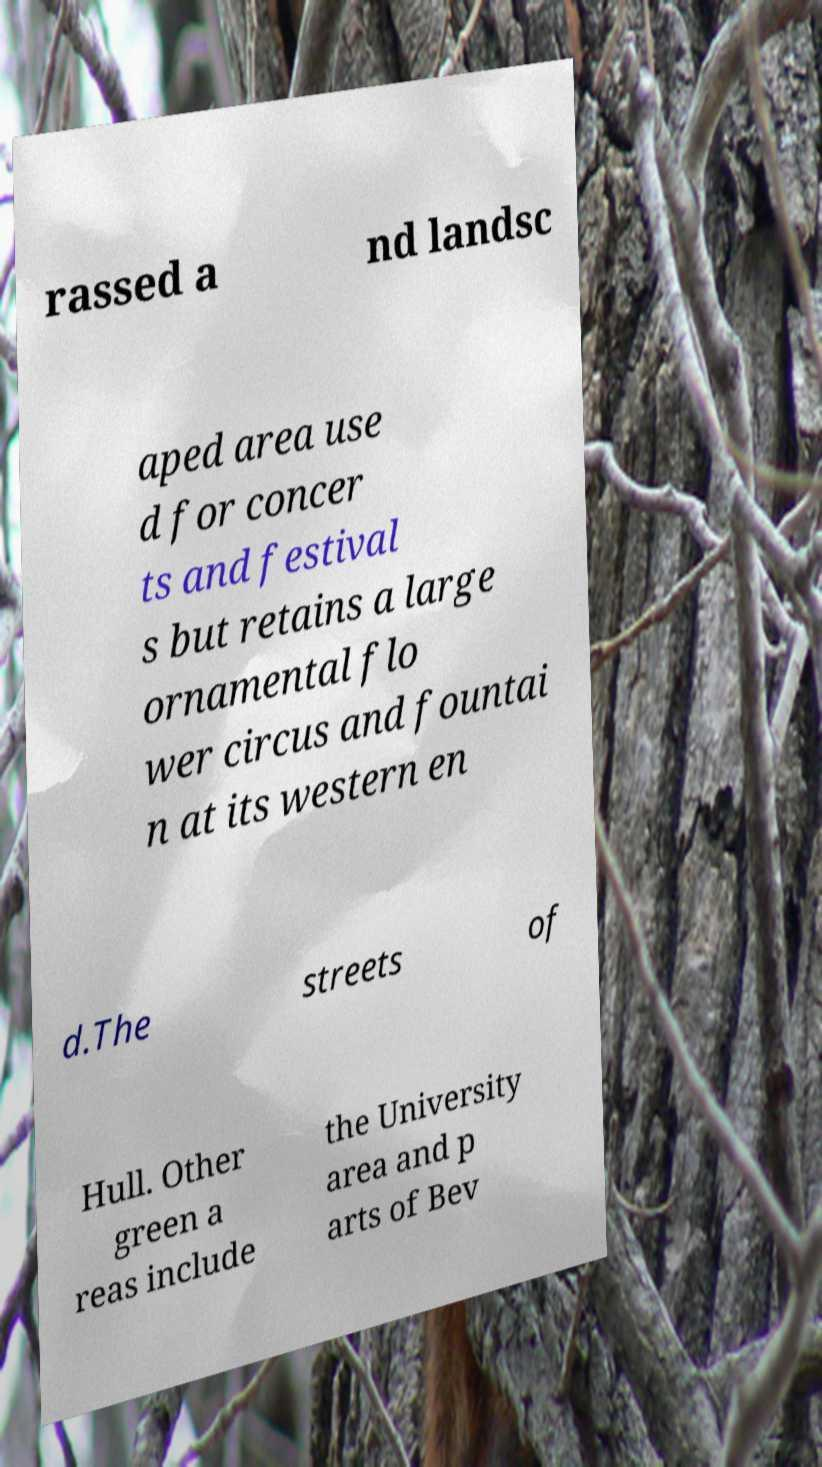Can you accurately transcribe the text from the provided image for me? rassed a nd landsc aped area use d for concer ts and festival s but retains a large ornamental flo wer circus and fountai n at its western en d.The streets of Hull. Other green a reas include the University area and p arts of Bev 